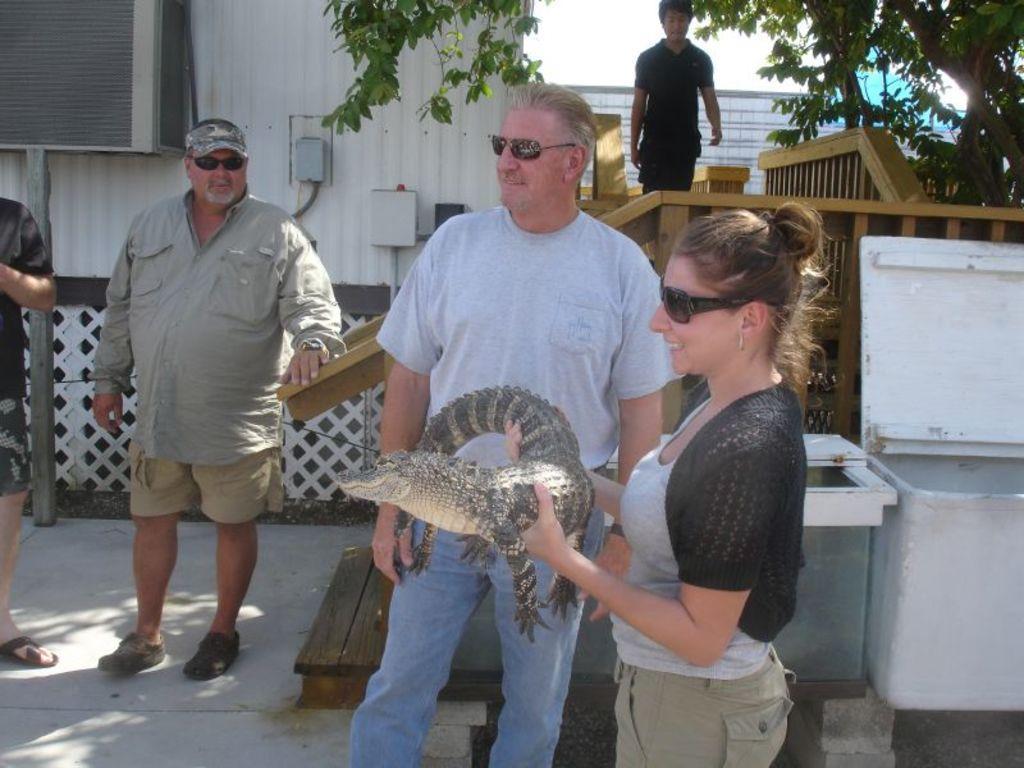Describe this image in one or two sentences. In this image we can see some people standing on the ground. In that a woman is holding a baby crocodile. We can also see some containers and a fence. We can also see the wooden railing, a tree, some metal boxes on a wall, a person standing and the sky which looks cloudy. 